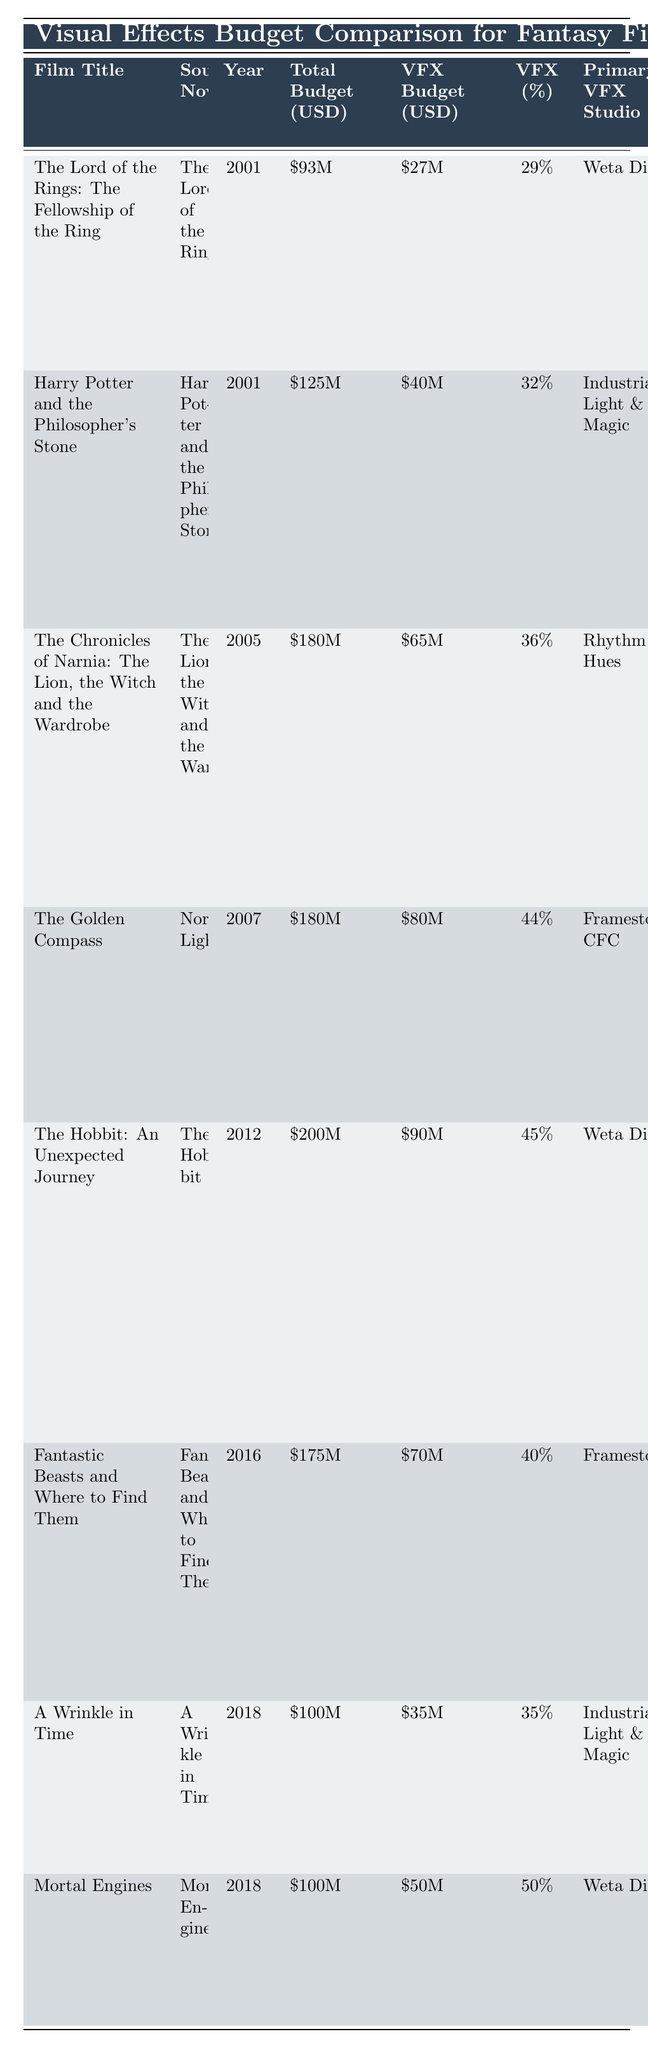What is the VFX budget for "The Golden Compass"? The VFX budget for "The Golden Compass" can be found in the table under the corresponding row for the film. It indicates a budget of 80 million USD.
Answer: 80 million USD Which film has the highest percentage of its budget allocated to VFX? By reviewing the VFX Budget (%) column, "Mortal Engines" has the highest allocation with 50% of its total budget directed to VFX.
Answer: "Mortal Engines" What is the difference in total budget between "Harry Potter and the Philosopher's Stone" and "A Wrinkle in Time"? The total budget for "Harry Potter and the Philosopher's Stone" is 125 million USD and for "A Wrinkle in Time" is 100 million USD. Therefore, the difference is 125 - 100 = 25 million USD.
Answer: 25 million USD Did "Fantastic Beasts and Where to Find Them" have a higher VFX budget than "The Hobbit: An Unexpected Journey"? The VFX budget for "Fantastic Beasts and Where to Find Them" is 70 million USD, while "The Hobbit: An Unexpected Journey" had a VFX budget of 90 million USD, which means "Fantastic Beasts" did not exceed it.
Answer: No What is the average total budget of the films listed? The total budgets of the films are (93 + 125 + 180 + 180 + 200 + 175 + 100 + 100) = 1153 million USD. There are 8 films, so the average total budget = 1153 / 8 = 144.125 million USD.
Answer: 144.125 million USD What is the notable VFX challenge for "The Lord of the Rings: The Fellowship of the Ring"? This information is found in the notable VFX challenges column, stating that it involves creating the Balrog and large-scale battle scenes.
Answer: Creating the Balrog and large-scale battle scenes Which primary VFX studio worked on both "The Hobbit: An Unexpected Journey" and "The Lord of the Rings: The Fellowship of the Ring"? By checking the Primary VFX Studio column, both films were worked on by Weta Digital, indicating they shared the same studio for their visual effects.
Answer: Weta Digital How much was spent on VFX for "The Chronicles of Narnia: The Lion, the Witch and the Wardrobe"? By looking at the specific row for "The Chronicles of Narnia," the VFX budget listed is 65 million USD.
Answer: 65 million USD 